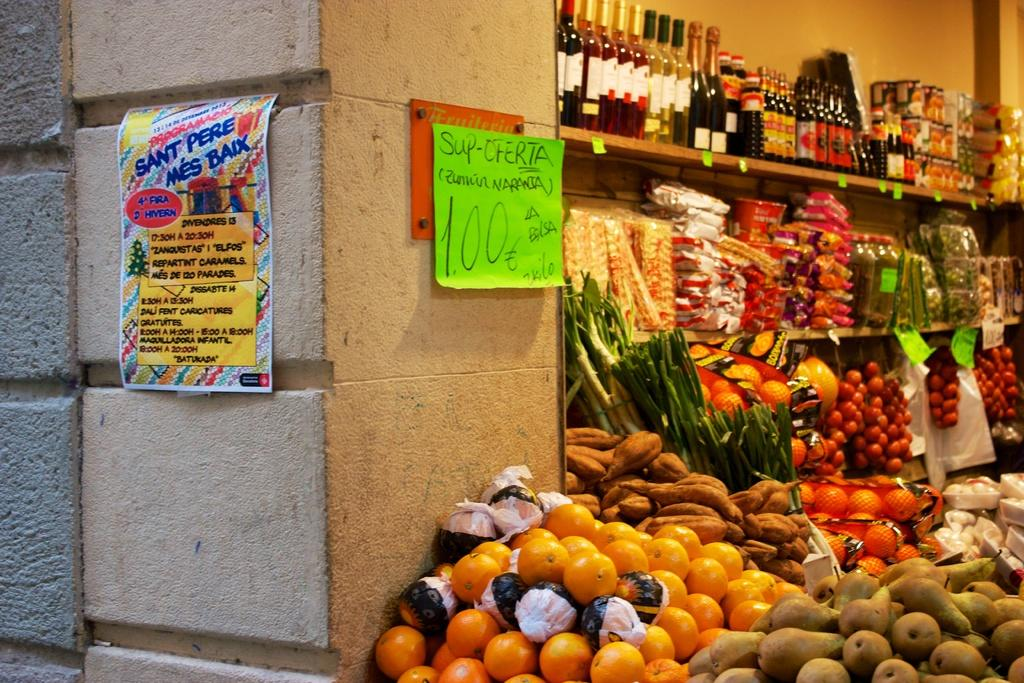What can be seen on the wall in the image? There is a paper stuck to the wall in the image. What is located behind the wall? There is a shelf behind the wall. What items are on the shelf? There are bottles, vegetables, and fruits on the shelf. What type of voyage is depicted in the image? There is no voyage depicted in the image; it features a wall with a paper and a shelf with various items. What action is the voice performing in the image? There is no voice or action involving a voice present in the image. 